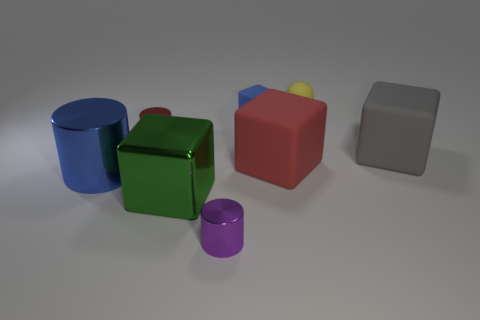Subtract 1 cubes. How many cubes are left? 3 Add 1 small purple rubber balls. How many objects exist? 9 Subtract all cylinders. How many objects are left? 5 Subtract all large shiny objects. Subtract all blue shiny things. How many objects are left? 5 Add 8 large blue things. How many large blue things are left? 9 Add 2 tiny purple metal cylinders. How many tiny purple metal cylinders exist? 3 Subtract 0 yellow cubes. How many objects are left? 8 